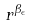<formula> <loc_0><loc_0><loc_500><loc_500>r ^ { \beta _ { \epsilon } }</formula> 